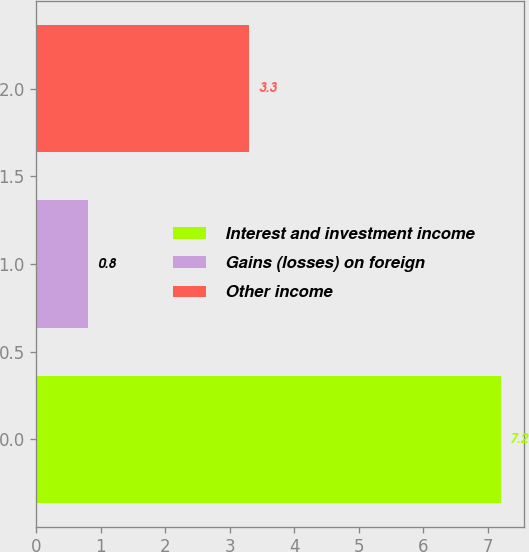Convert chart to OTSL. <chart><loc_0><loc_0><loc_500><loc_500><bar_chart><fcel>Interest and investment income<fcel>Gains (losses) on foreign<fcel>Other income<nl><fcel>7.2<fcel>0.8<fcel>3.3<nl></chart> 